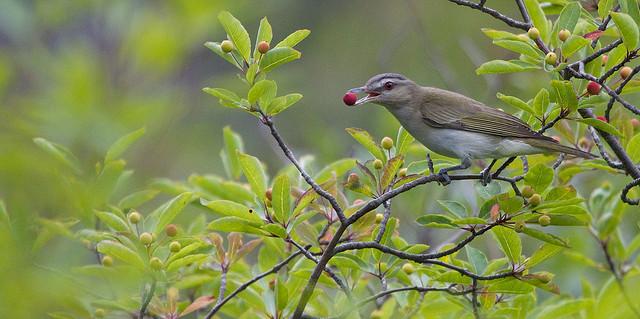What is the bird standing on?
Answer briefly. Branch. Which way is the bird facing?
Answer briefly. Left. Is this bird looking for food?
Write a very short answer. Yes. What kind of bird is this?
Keep it brief. Sparrow. What is the bird eating from?
Quick response, please. Tree. Is the bird eating?
Short answer required. Yes. Is this a female bird?
Short answer required. Yes. 